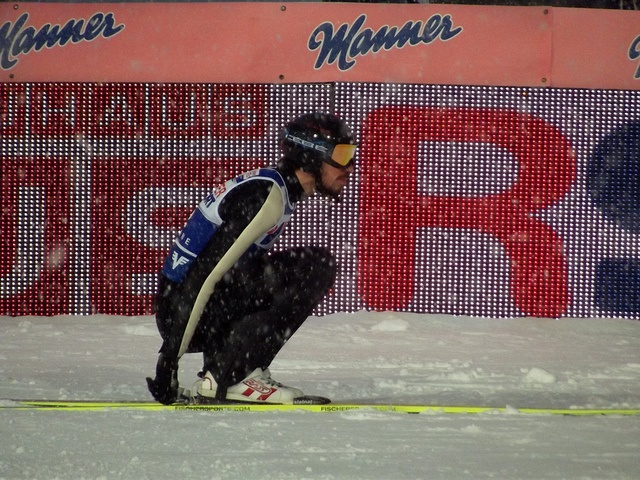Describe the objects in this image and their specific colors. I can see people in black, gray, and darkgray tones in this image. 